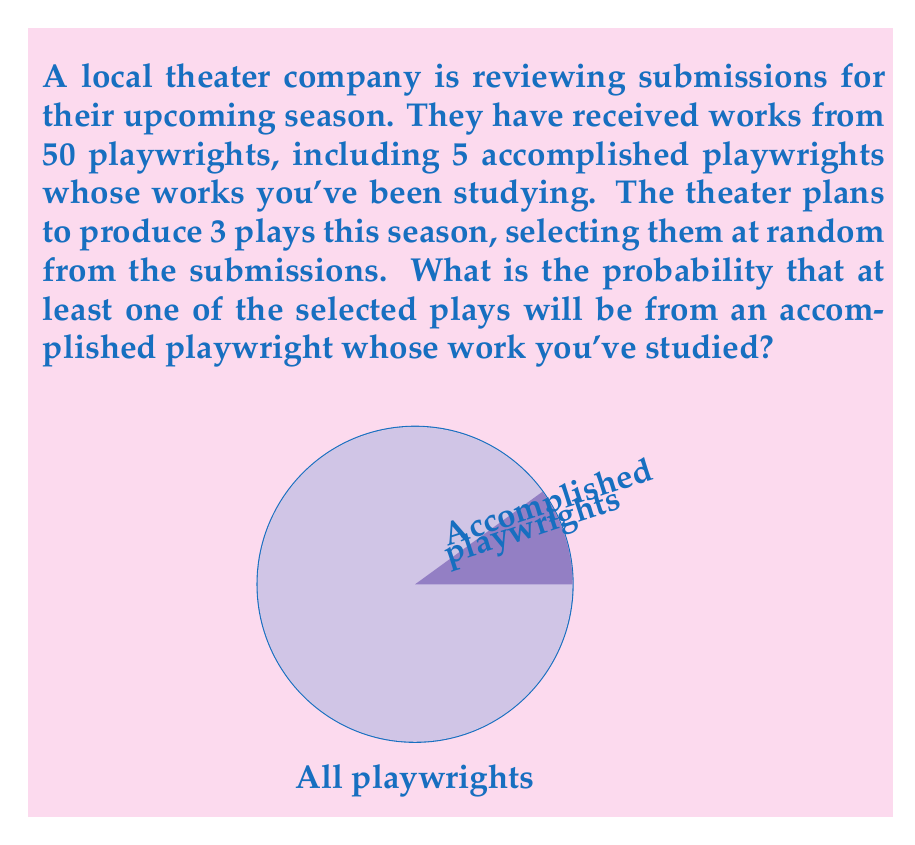Give your solution to this math problem. Let's approach this step-by-step:

1) First, let's calculate the probability of selecting a play that is not from an accomplished playwright:
   $$P(\text{not accomplished}) = \frac{45}{50} = 0.9$$

2) Now, the probability of all three selected plays not being from accomplished playwrights is:
   $$P(\text{all not accomplished}) = 0.9 \times 0.9 \times 0.9 = 0.9^3 = 0.729$$

3) Therefore, the probability of at least one play being from an accomplished playwright is the complement of this probability:
   $$P(\text{at least one accomplished}) = 1 - P(\text{all not accomplished})$$
   $$= 1 - 0.729 = 0.271$$

4) We can also calculate this using the combination formula:
   $$1 - \frac{\binom{45}{3}}{\binom{50}{3}} = 1 - \frac{14190}{19600} = 0.271$$

5) Converting to a percentage:
   $$0.271 \times 100\% = 27.1\%$$
Answer: 27.1% 